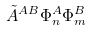<formula> <loc_0><loc_0><loc_500><loc_500>\tilde { A } ^ { A B } \Phi _ { n } ^ { A } \Phi _ { m } ^ { B }</formula> 